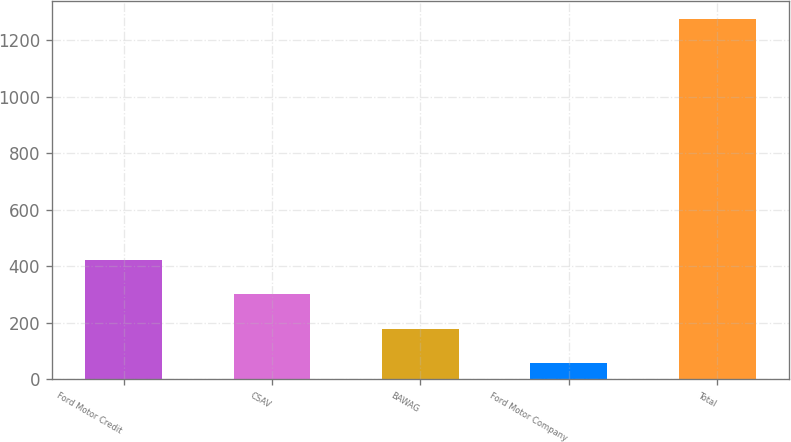Convert chart. <chart><loc_0><loc_0><loc_500><loc_500><bar_chart><fcel>Ford Motor Credit<fcel>CSAV<fcel>BAWAG<fcel>Ford Motor Company<fcel>Total<nl><fcel>422.1<fcel>300.4<fcel>178.7<fcel>57<fcel>1274<nl></chart> 